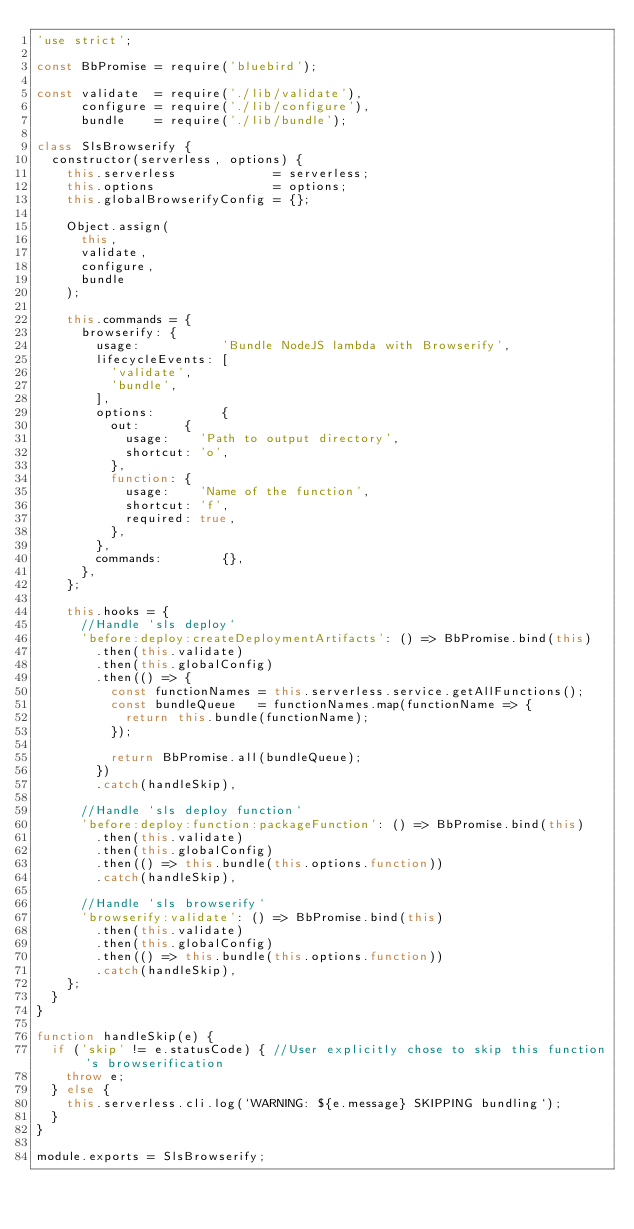Convert code to text. <code><loc_0><loc_0><loc_500><loc_500><_JavaScript_>'use strict';

const BbPromise = require('bluebird');

const validate  = require('./lib/validate'),
      configure = require('./lib/configure'),
      bundle    = require('./lib/bundle');

class SlsBrowserify {
  constructor(serverless, options) {
    this.serverless             = serverless;
    this.options                = options;
    this.globalBrowserifyConfig = {};

    Object.assign(
      this,
      validate,
      configure,
      bundle
    );

    this.commands = {
      browserify: {
        usage:           'Bundle NodeJS lambda with Browserify',
        lifecycleEvents: [
          'validate',
          'bundle',
        ],
        options:         {
          out:      {
            usage:    'Path to output directory',
            shortcut: 'o',
          },
          function: {
            usage:    'Name of the function',
            shortcut: 'f',
            required: true,
          },
        },
        commands:        {},
      },
    };

    this.hooks = {
      //Handle `sls deploy`
      'before:deploy:createDeploymentArtifacts': () => BbPromise.bind(this)
        .then(this.validate)
        .then(this.globalConfig)
        .then(() => {
          const functionNames = this.serverless.service.getAllFunctions();
          const bundleQueue   = functionNames.map(functionName => {
            return this.bundle(functionName);
          });

          return BbPromise.all(bundleQueue);
        })
        .catch(handleSkip),

      //Handle `sls deploy function`
      'before:deploy:function:packageFunction': () => BbPromise.bind(this)
        .then(this.validate)
        .then(this.globalConfig)
        .then(() => this.bundle(this.options.function))
        .catch(handleSkip),

      //Handle `sls browserify`
      'browserify:validate': () => BbPromise.bind(this)
        .then(this.validate)
        .then(this.globalConfig)
        .then(() => this.bundle(this.options.function))
        .catch(handleSkip),
    };
  }
}

function handleSkip(e) {
  if ('skip' != e.statusCode) { //User explicitly chose to skip this function's browserification
    throw e;
  } else {
    this.serverless.cli.log(`WARNING: ${e.message} SKIPPING bundling`);
  }
}

module.exports = SlsBrowserify;
</code> 